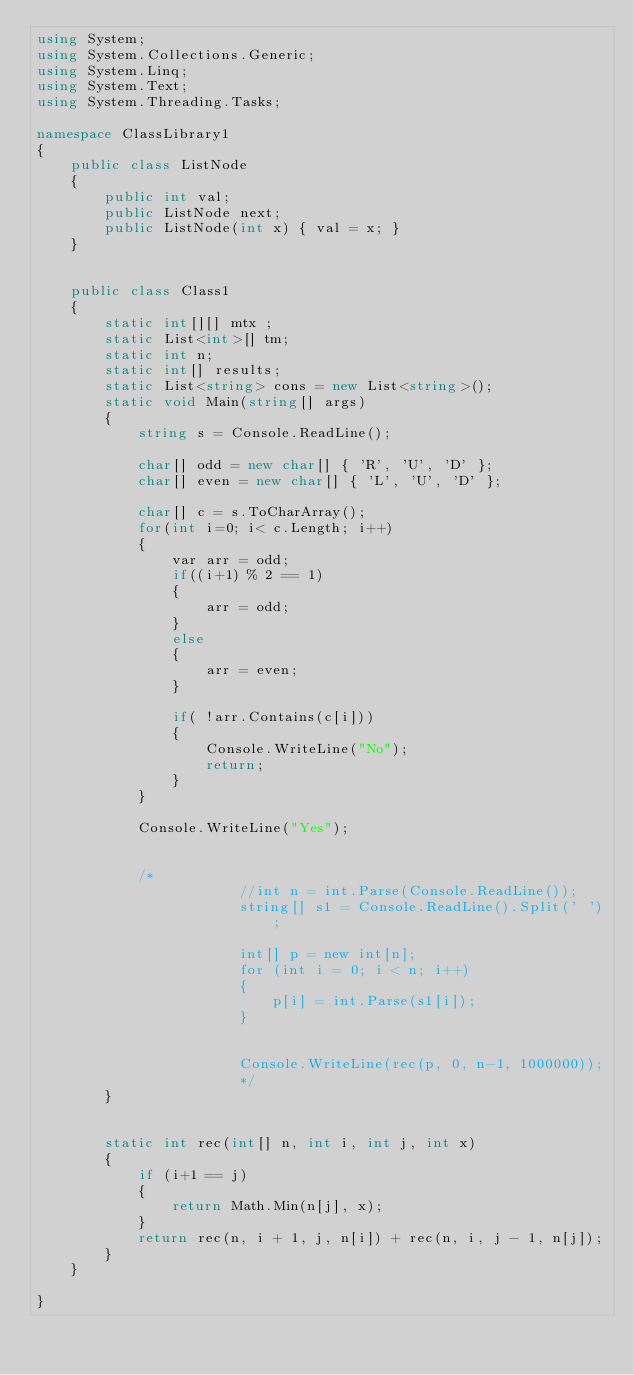<code> <loc_0><loc_0><loc_500><loc_500><_C#_>using System;
using System.Collections.Generic;
using System.Linq;
using System.Text;
using System.Threading.Tasks;

namespace ClassLibrary1
{
    public class ListNode
    {
        public int val;
        public ListNode next;
        public ListNode(int x) { val = x; }
    }


    public class Class1
    {
        static int[][] mtx ;
        static List<int>[] tm;
        static int n;
        static int[] results;
        static List<string> cons = new List<string>();
        static void Main(string[] args)
        {
            string s = Console.ReadLine();

            char[] odd = new char[] { 'R', 'U', 'D' };
            char[] even = new char[] { 'L', 'U', 'D' };

            char[] c = s.ToCharArray();
            for(int i=0; i< c.Length; i++)
            {
                var arr = odd;
                if((i+1) % 2 == 1)
                {
                    arr = odd;
                }
                else
                {
                    arr = even;
                }

                if( !arr.Contains(c[i]))
                {
                    Console.WriteLine("No");
                    return;
                }
            }

            Console.WriteLine("Yes");


            /*
                        //int n = int.Parse(Console.ReadLine());
                        string[] s1 = Console.ReadLine().Split(' ');

                        int[] p = new int[n];
                        for (int i = 0; i < n; i++)
                        {
                            p[i] = int.Parse(s1[i]);
                        }


                        Console.WriteLine(rec(p, 0, n-1, 1000000));
                        */
        }


        static int rec(int[] n, int i, int j, int x)
        {
            if (i+1 == j)
            {
                return Math.Min(n[j], x);
            }
            return rec(n, i + 1, j, n[i]) + rec(n, i, j - 1, n[j]);
        }
    }

}</code> 